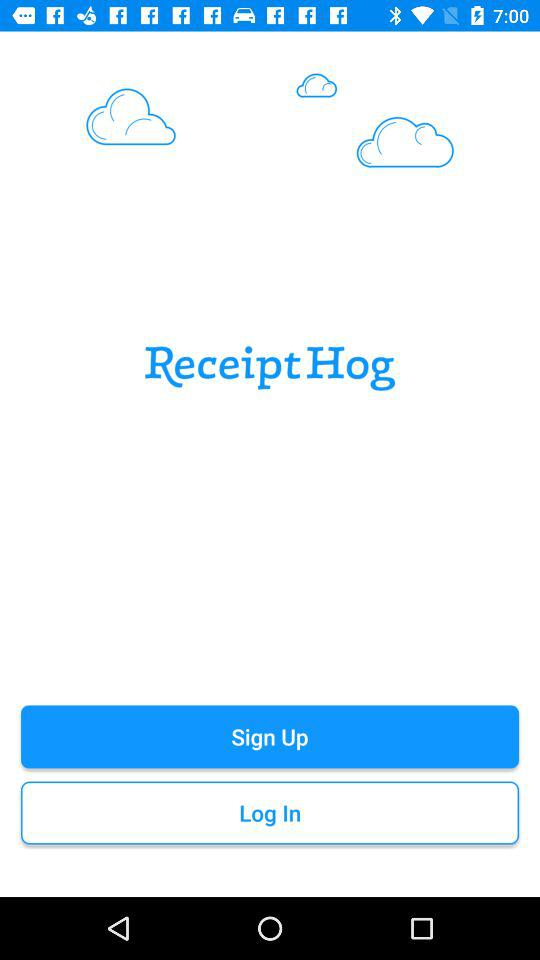What is the name of the application? The name of the application is "Receipt Hog". 